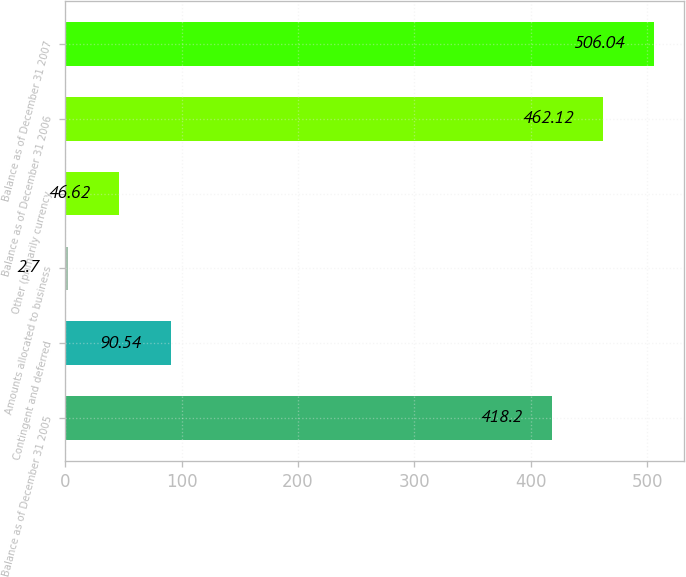Convert chart. <chart><loc_0><loc_0><loc_500><loc_500><bar_chart><fcel>Balance as of December 31 2005<fcel>Contingent and deferred<fcel>Amounts allocated to business<fcel>Other (primarily currency<fcel>Balance as of December 31 2006<fcel>Balance as of December 31 2007<nl><fcel>418.2<fcel>90.54<fcel>2.7<fcel>46.62<fcel>462.12<fcel>506.04<nl></chart> 